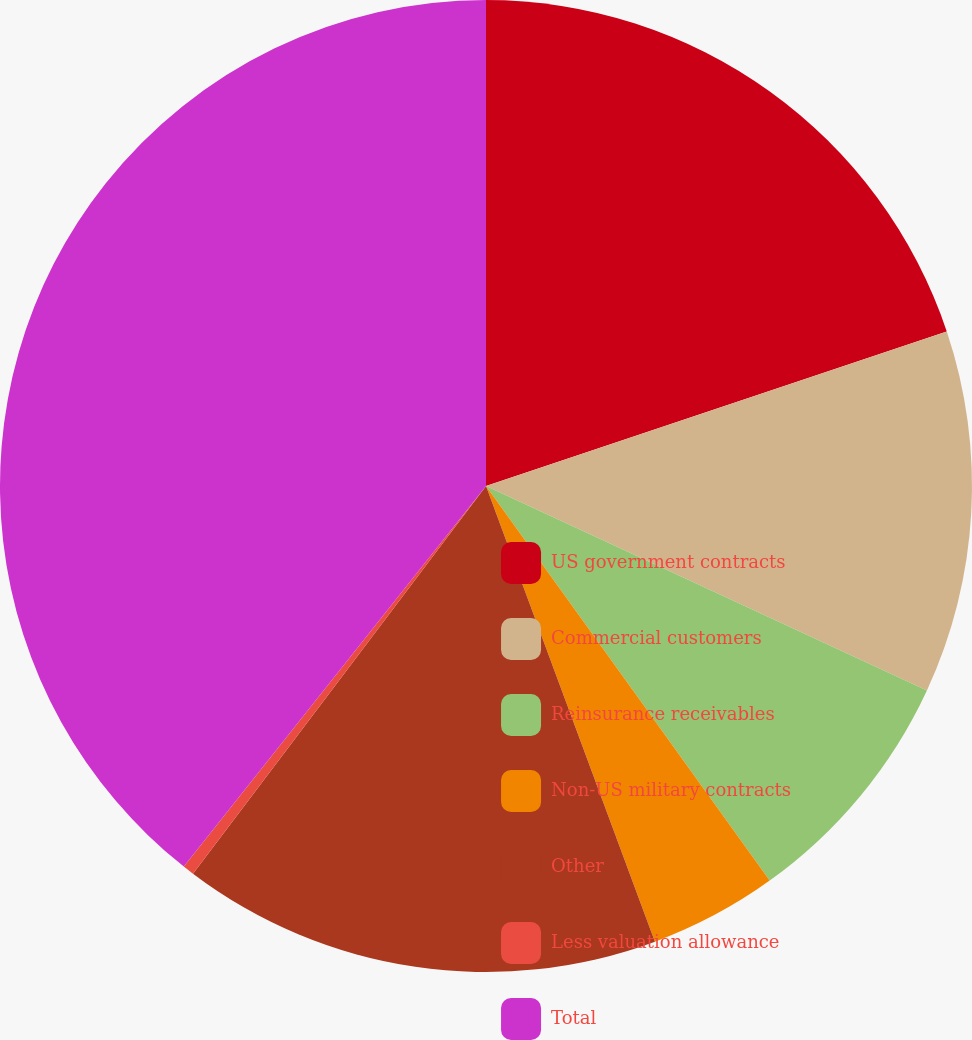Convert chart. <chart><loc_0><loc_0><loc_500><loc_500><pie_chart><fcel>US government contracts<fcel>Commercial customers<fcel>Reinsurance receivables<fcel>Non-US military contracts<fcel>Other<fcel>Less valuation allowance<fcel>Total<nl><fcel>19.85%<fcel>12.06%<fcel>8.17%<fcel>4.27%<fcel>15.95%<fcel>0.38%<fcel>39.32%<nl></chart> 